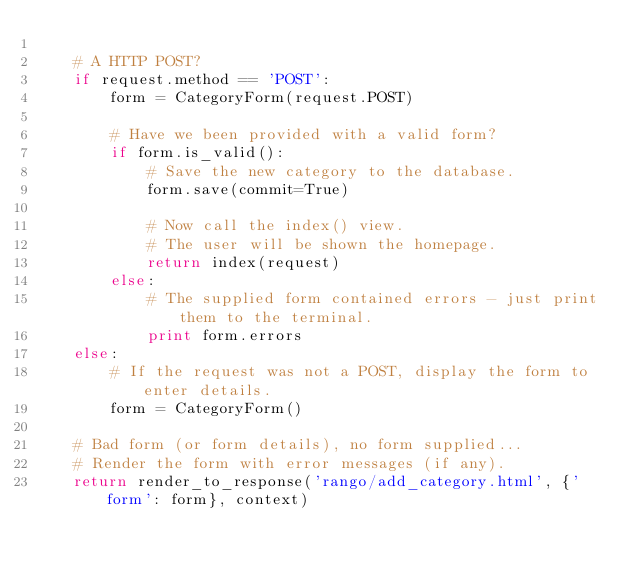Convert code to text. <code><loc_0><loc_0><loc_500><loc_500><_Python_>
    # A HTTP POST?
    if request.method == 'POST':
        form = CategoryForm(request.POST)

        # Have we been provided with a valid form?
        if form.is_valid():
            # Save the new category to the database.
            form.save(commit=True)

            # Now call the index() view.
            # The user will be shown the homepage.
            return index(request)
        else:
            # The supplied form contained errors - just print them to the terminal.
            print form.errors
    else:
        # If the request was not a POST, display the form to enter details.
        form = CategoryForm()

    # Bad form (or form details), no form supplied...
    # Render the form with error messages (if any).
    return render_to_response('rango/add_category.html', {'form': form}, context)
</code> 